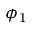Convert formula to latex. <formula><loc_0><loc_0><loc_500><loc_500>\phi _ { 1 }</formula> 